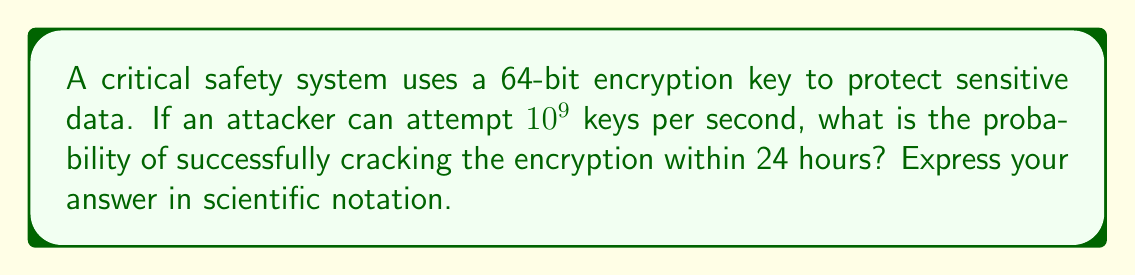Teach me how to tackle this problem. Let's approach this step-by-step:

1) First, we need to calculate the total number of possible keys:
   $$ \text{Total keys} = 2^{64} $$

2) Next, we calculate how many keys the attacker can try in 24 hours:
   $$ \text{Keys tried} = 10^9 \text{ keys/second} \times 24 \text{ hours} \times 3600 \text{ seconds/hour} = 8.64 \times 10^{13} \text{ keys} $$

3) The probability of success is the number of keys tried divided by the total number of possible keys:
   $$ P(\text{success}) = \frac{\text{Keys tried}}{\text{Total keys}} = \frac{8.64 \times 10^{13}}{2^{64}} $$

4) Let's calculate $2^{64}$:
   $$ 2^{64} \approx 1.8447 \times 10^{19} $$

5) Now we can calculate the probability:
   $$ P(\text{success}) = \frac{8.64 \times 10^{13}}{1.8447 \times 10^{19}} \approx 4.684 \times 10^{-6} $$

6) Rounding to 3 significant figures:
   $$ P(\text{success}) \approx 4.68 \times 10^{-6} $$

This extremely low probability demonstrates the strength of 64-bit encryption in protecting critical safety systems against brute-force attacks, aligning with the persona's belief in not compromising on traditional safety norms.
Answer: $4.68 \times 10^{-6}$ 